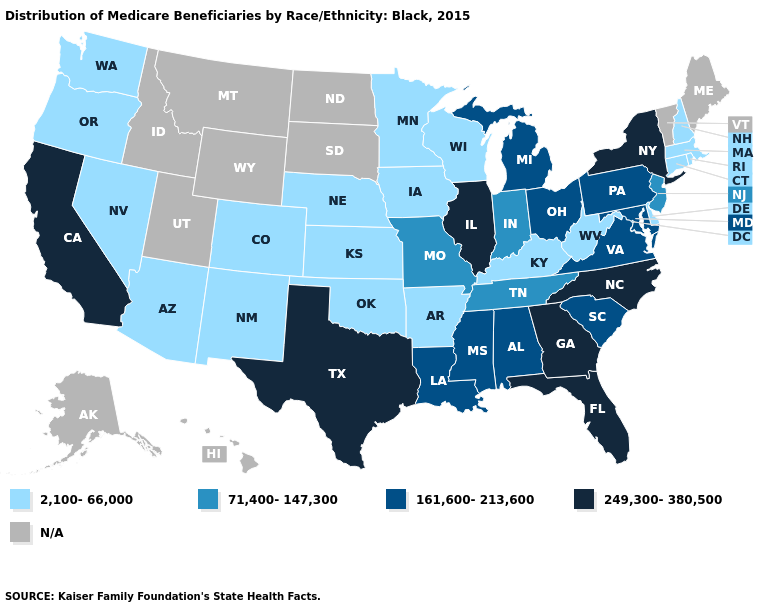What is the value of West Virginia?
Keep it brief. 2,100-66,000. What is the highest value in the West ?
Answer briefly. 249,300-380,500. Is the legend a continuous bar?
Write a very short answer. No. Name the states that have a value in the range 249,300-380,500?
Write a very short answer. California, Florida, Georgia, Illinois, New York, North Carolina, Texas. What is the lowest value in states that border Maine?
Give a very brief answer. 2,100-66,000. Does the map have missing data?
Be succinct. Yes. Which states hav the highest value in the West?
Quick response, please. California. What is the value of Maryland?
Write a very short answer. 161,600-213,600. What is the value of Virginia?
Give a very brief answer. 161,600-213,600. Name the states that have a value in the range 2,100-66,000?
Concise answer only. Arizona, Arkansas, Colorado, Connecticut, Delaware, Iowa, Kansas, Kentucky, Massachusetts, Minnesota, Nebraska, Nevada, New Hampshire, New Mexico, Oklahoma, Oregon, Rhode Island, Washington, West Virginia, Wisconsin. How many symbols are there in the legend?
Write a very short answer. 5. 